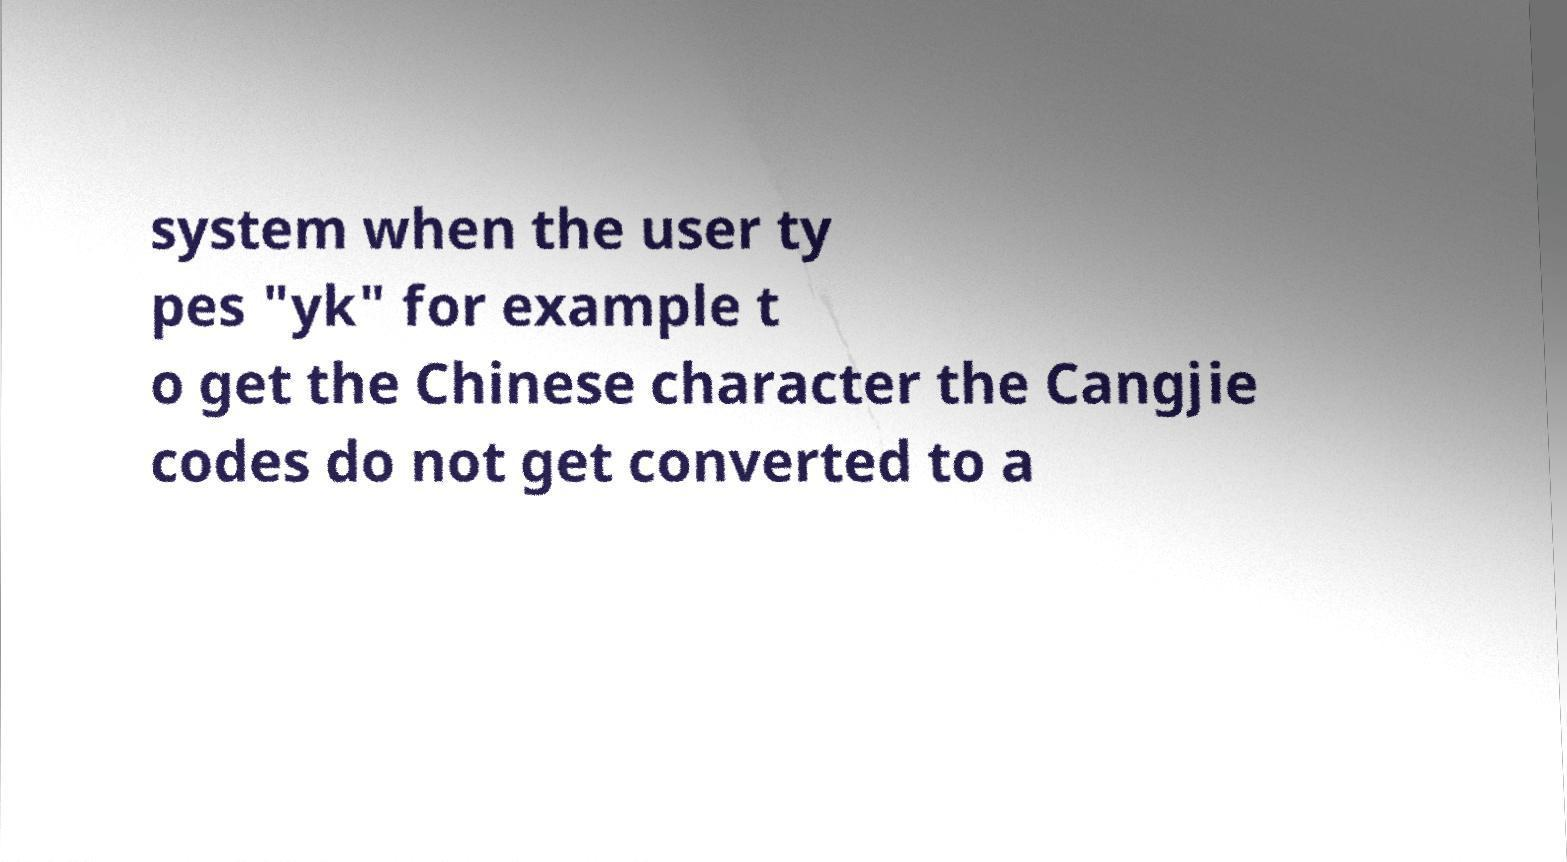Can you read and provide the text displayed in the image?This photo seems to have some interesting text. Can you extract and type it out for me? system when the user ty pes "yk" for example t o get the Chinese character the Cangjie codes do not get converted to a 